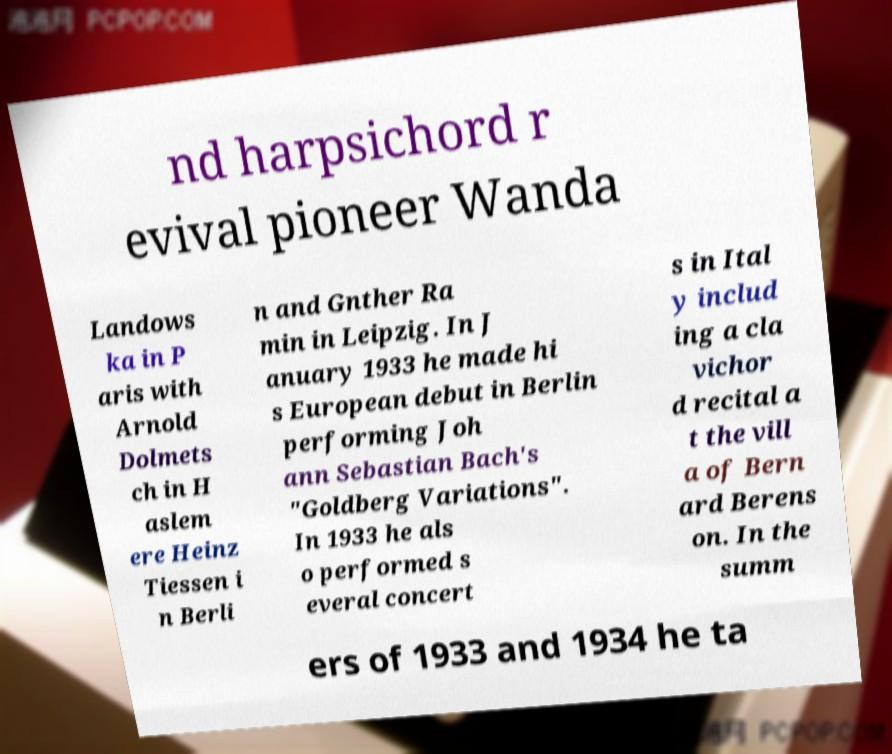What messages or text are displayed in this image? I need them in a readable, typed format. nd harpsichord r evival pioneer Wanda Landows ka in P aris with Arnold Dolmets ch in H aslem ere Heinz Tiessen i n Berli n and Gnther Ra min in Leipzig. In J anuary 1933 he made hi s European debut in Berlin performing Joh ann Sebastian Bach's "Goldberg Variations". In 1933 he als o performed s everal concert s in Ital y includ ing a cla vichor d recital a t the vill a of Bern ard Berens on. In the summ ers of 1933 and 1934 he ta 